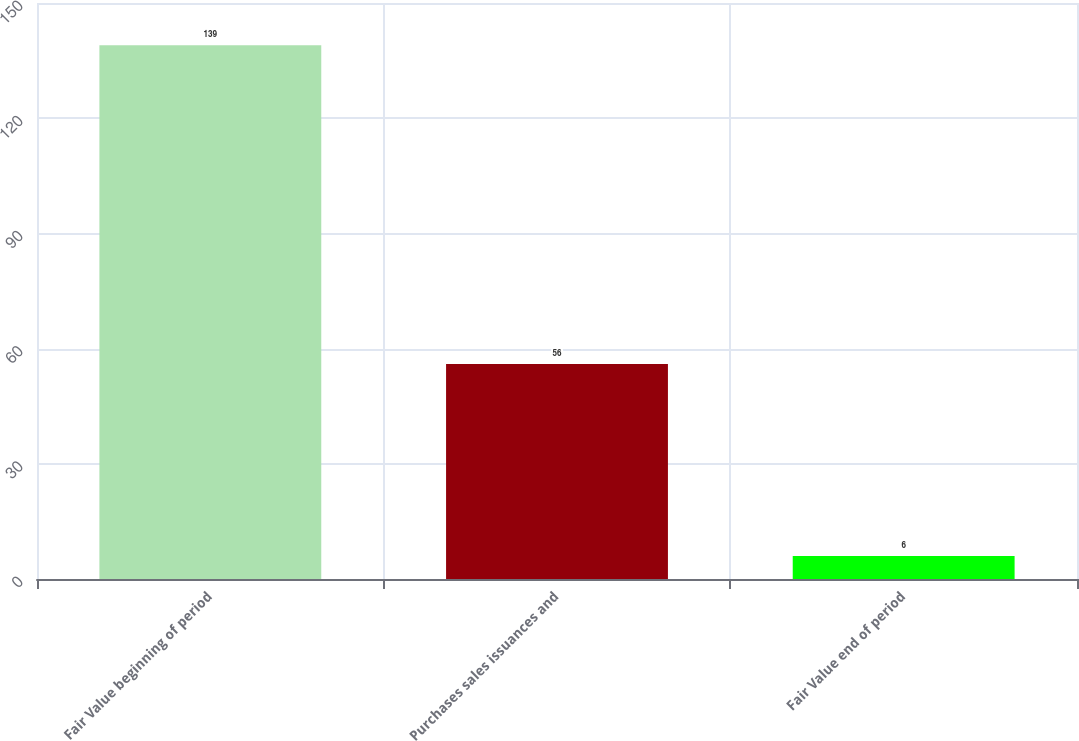<chart> <loc_0><loc_0><loc_500><loc_500><bar_chart><fcel>Fair Value beginning of period<fcel>Purchases sales issuances and<fcel>Fair Value end of period<nl><fcel>139<fcel>56<fcel>6<nl></chart> 